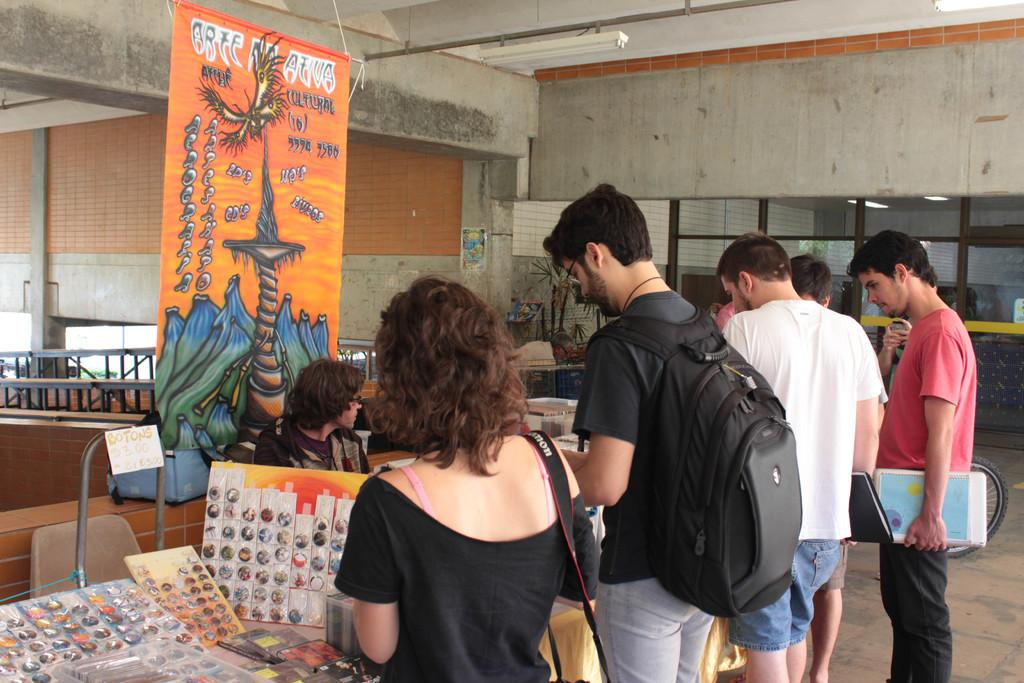How many people can be seen in the image? There are many people in the image. What is located on the left side of the image? There is a table on the left side of the image. What is placed on the table? Charts are present on the table. What can be seen in the background of the image? There is a banner and walls visible in the background of the image. What architectural features are present in the background of the image? Pillars are present in the background of the image. What type of polish is being applied to the bells in the image? There are no bells present in the image, so it is not possible to determine if any polish is being applied. 